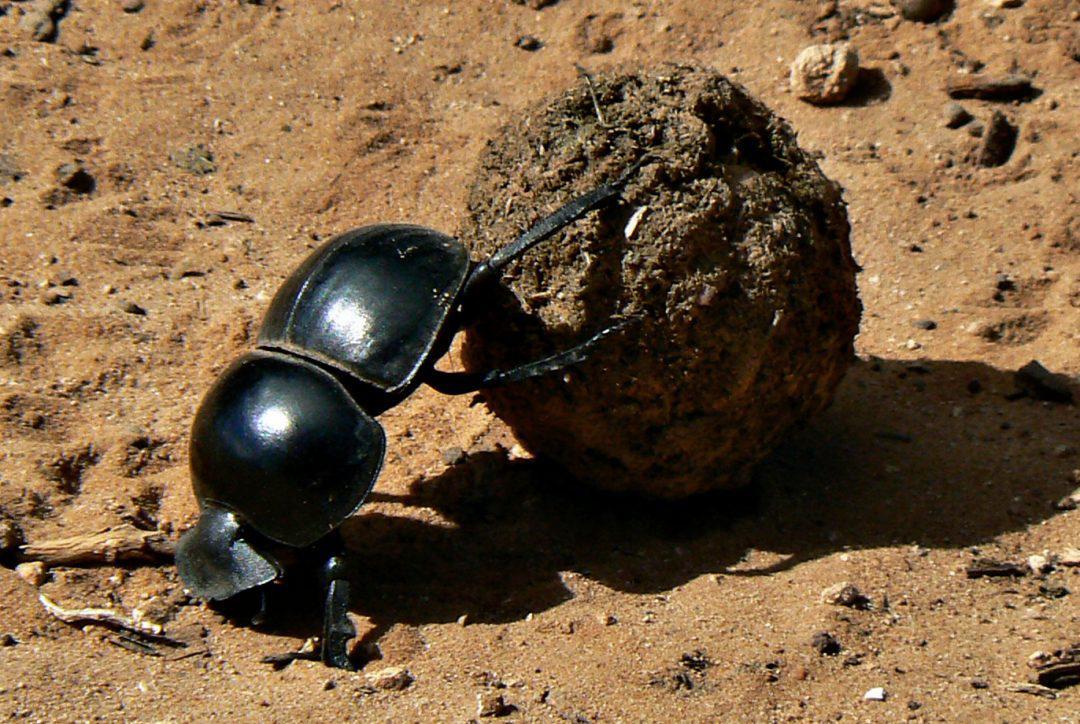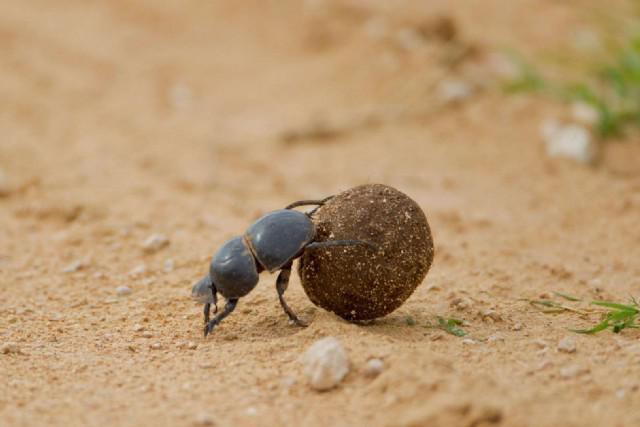The first image is the image on the left, the second image is the image on the right. Analyze the images presented: Is the assertion "There are two dogs standing in the dirt in one of the images." valid? Answer yes or no. No. 